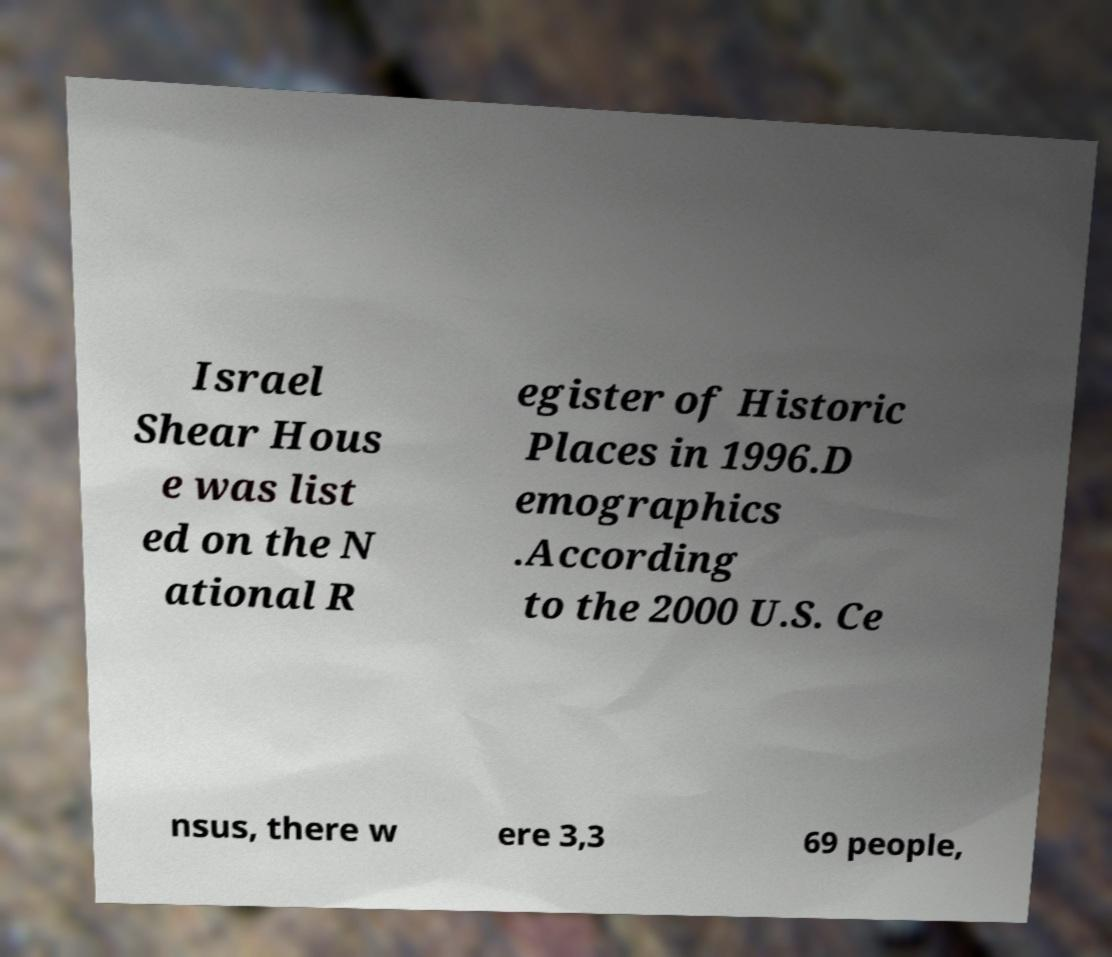What messages or text are displayed in this image? I need them in a readable, typed format. Israel Shear Hous e was list ed on the N ational R egister of Historic Places in 1996.D emographics .According to the 2000 U.S. Ce nsus, there w ere 3,3 69 people, 